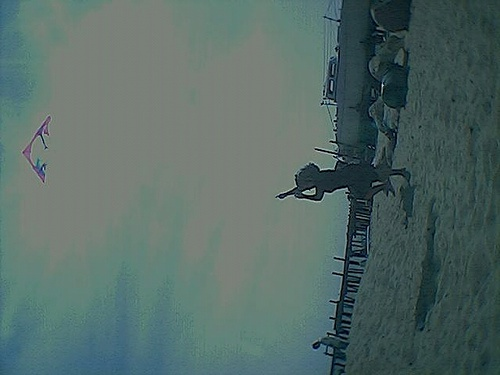Describe the objects in this image and their specific colors. I can see boat in teal, purple, black, darkblue, and gray tones, people in teal, black, darkblue, gray, and purple tones, kite in teal and gray tones, and people in teal, navy, blue, darkblue, and gray tones in this image. 